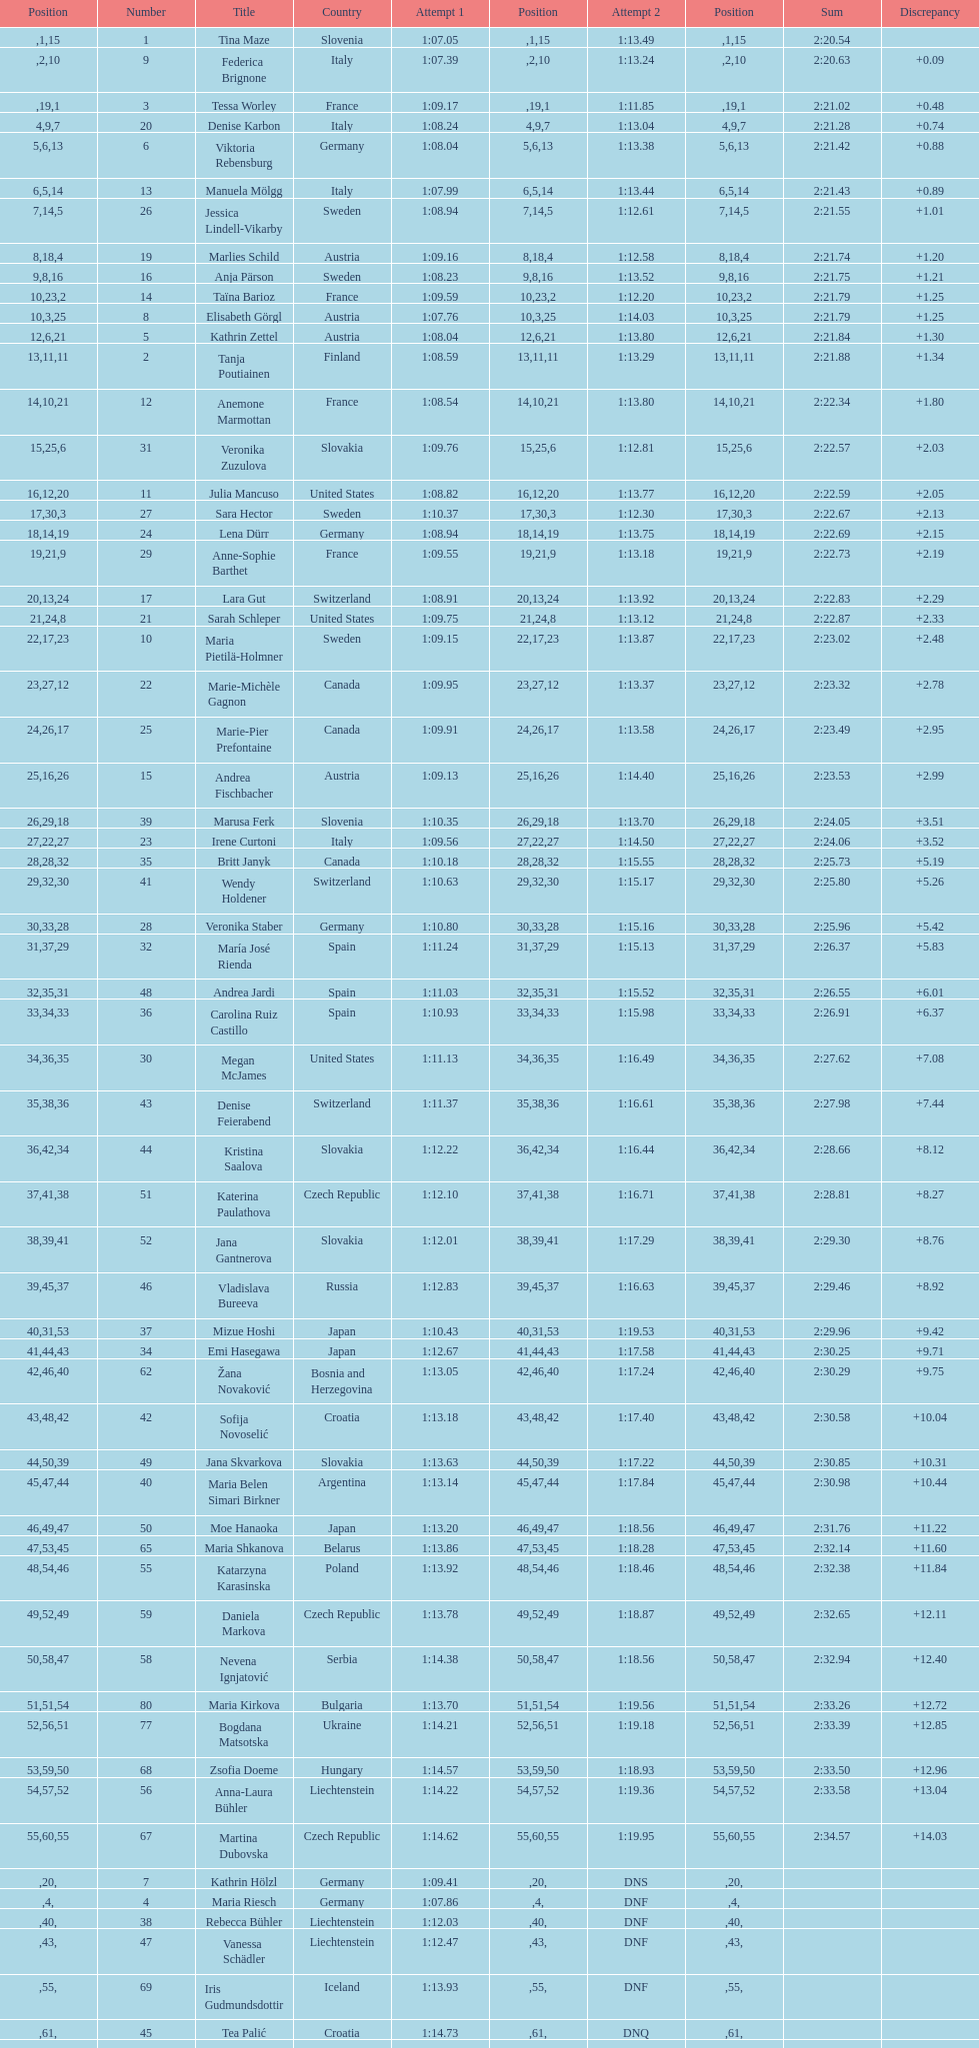How many italians finished in the top ten? 3. 